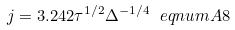<formula> <loc_0><loc_0><loc_500><loc_500>j = 3 . 2 4 2 \tau ^ { 1 / 2 } \Delta ^ { - 1 / 4 } \ e q n u m { A 8 }</formula> 